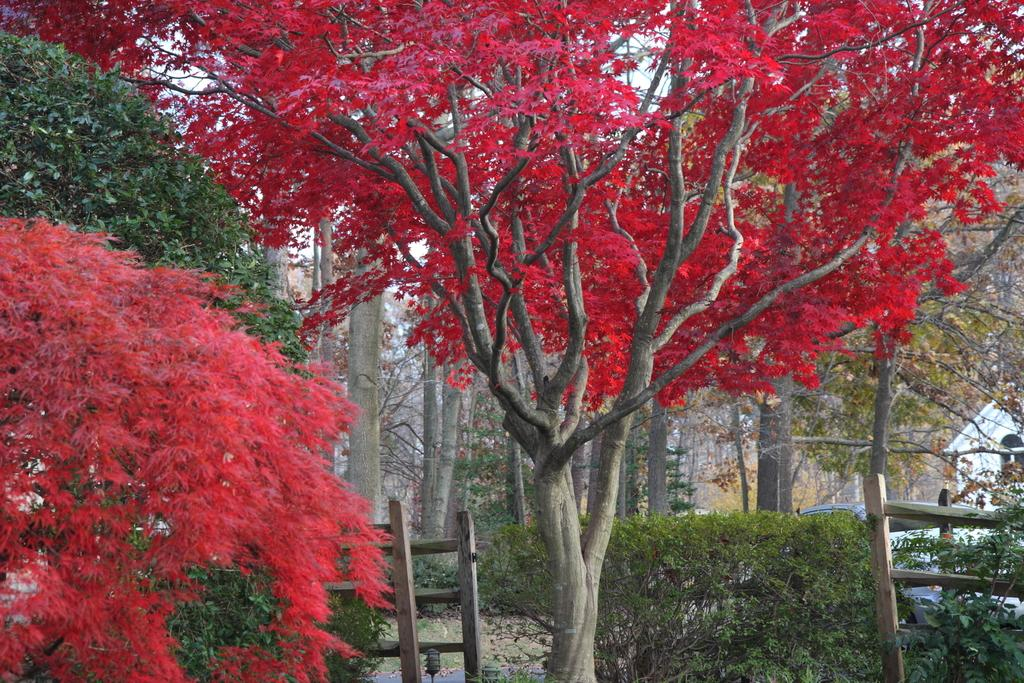What type of vegetation can be seen in the image? There are trees in the image. What part of the natural environment is visible in the image? The sky is visible in the background of the image. What color is the spy's hat in the image? There is no spy or hat present in the image; it features trees and the sky. How many oranges are hanging from the trees in the image? There are no oranges visible in the image; it only shows trees and the sky. 